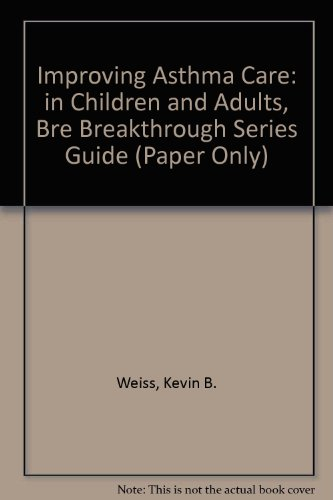Who wrote this book? The author of the book is Kevin B. Weiss, as indicated on the cover. 